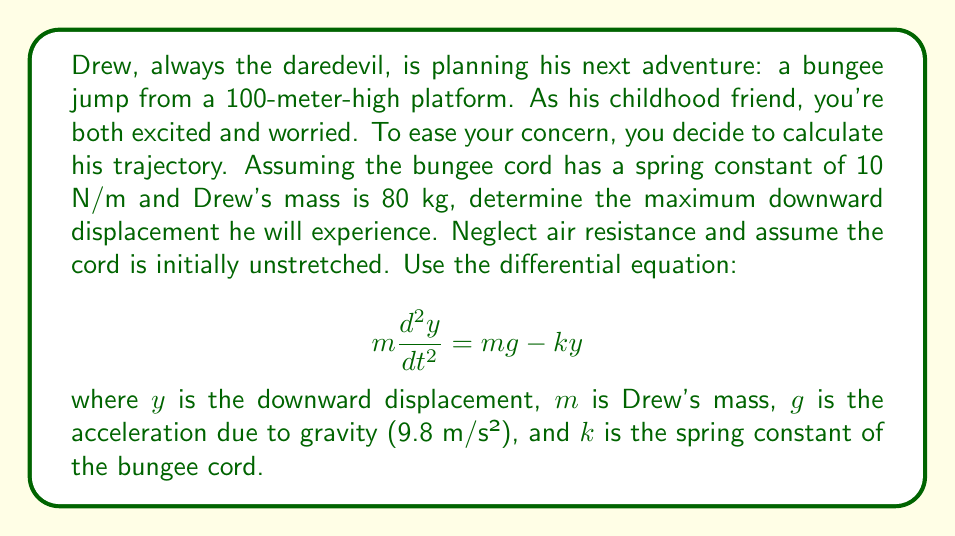Can you answer this question? To solve this problem, we'll follow these steps:

1) First, we need to find the equilibrium position. This is where the gravitational force equals the spring force:

   $$mg = ky_e$$
   $$80 \cdot 9.8 = 10y_e$$
   $$y_e = 78.4 \text{ m}$$

2) Now, we can write our differential equation in terms of displacement from equilibrium. Let $x = y - y_e$:

   $$m\frac{d^2x}{dt^2} = -kx$$

3) This is the equation for simple harmonic motion. The solution is:

   $$x = A\cos(\omega t + \phi)$$

   where $\omega = \sqrt{\frac{k}{m}} = \sqrt{\frac{10}{80}} = \frac{\sqrt{5}}{4} \text{ rad/s}$

4) To find $A$, we use the initial conditions. At $t=0$, $x = -y_e$ and $\frac{dx}{dt} = 0$:

   $$-y_e = A\cos(\phi)$$
   $$0 = -A\omega\sin(\phi)$$

   This implies $\phi = 0$ and $A = y_e = 78.4 \text{ m}$

5) So, the solution for $x$ is:

   $$x = 78.4\cos(\frac{\sqrt{5}}{4}t)$$

6) To get $y$, we add $y_e$:

   $$y = 78.4\cos(\frac{\sqrt{5}}{4}t) + 78.4$$

7) The maximum downward displacement occurs when $\cos(\frac{\sqrt{5}}{4}t) = 1$:

   $$y_{max} = 78.4 + 78.4 = 156.8 \text{ m}$$
Answer: 156.8 m 